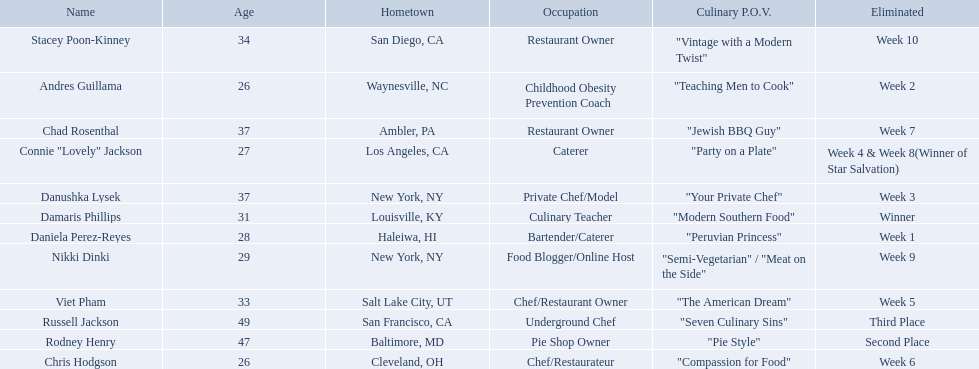Excluding the winner, and second and third place winners, who were the contestants eliminated? Stacey Poon-Kinney, Nikki Dinki, Chad Rosenthal, Chris Hodgson, Viet Pham, Connie "Lovely" Jackson, Danushka Lysek, Andres Guillama, Daniela Perez-Reyes. Of these contestants, who were the last five eliminated before the winner, second, and third place winners were announce? Stacey Poon-Kinney, Nikki Dinki, Chad Rosenthal, Chris Hodgson, Viet Pham. Of these five contestants, was nikki dinki or viet pham eliminated first? Viet Pham. 